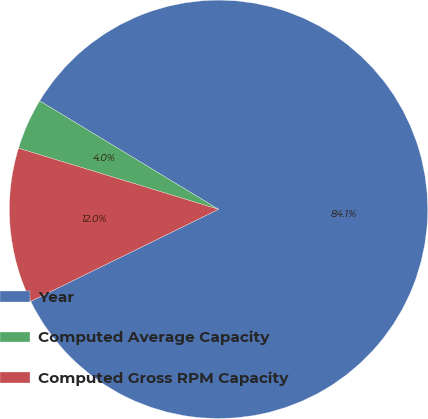Convert chart to OTSL. <chart><loc_0><loc_0><loc_500><loc_500><pie_chart><fcel>Year<fcel>Computed Average Capacity<fcel>Computed Gross RPM Capacity<nl><fcel>84.07%<fcel>3.96%<fcel>11.97%<nl></chart> 